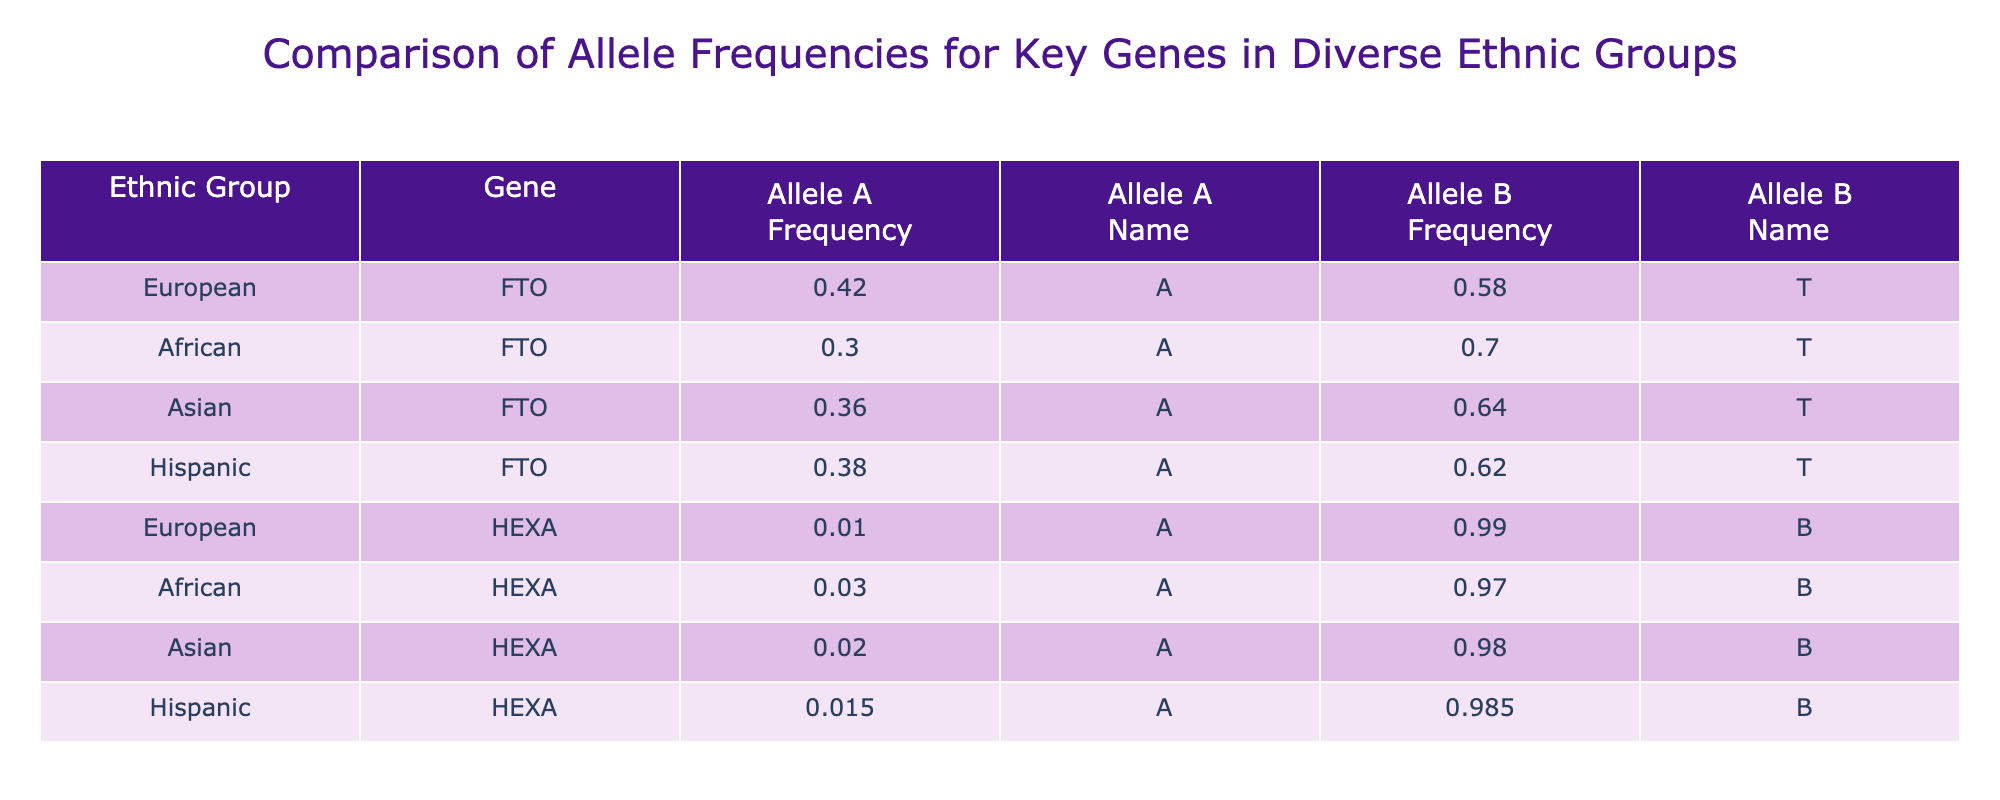What is the allele A frequency for the FTO gene in the African group? The table shows that for the FTO gene in the African group, the Allele A Frequency is 0.30.
Answer: 0.30 Which ethnic group has the highest frequency of Allele A for the HEXA gene? Looking at the HEXA gene rows, the frequencies of Allele A are 0.01 for European, 0.03 for African, 0.02 for Asian, and 0.015 for Hispanic. The European group has the highest frequency of 0.01.
Answer: European What is the total frequency of Allele B across all ethnic groups for the FTO gene? For the FTO gene, the frequencies of Allele B are 0.58 for European, 0.70 for African, 0.64 for Asian, and 0.62 for Hispanic. Adding these gives 0.58 + 0.70 + 0.64 + 0.62 = 2.54.
Answer: 2.54 Is the frequency of Allele A for the FTO gene higher in the Hispanic group than in the Asian group? The frequency of Allele A for FTO in Hispanic is 0.38, while for Asian it is 0.36. Since 0.38 is greater than 0.36, the statement is true.
Answer: Yes What is the average frequency of Allele A for the HEXA gene among the ethnic groups listed? To find the average frequency of Allele A for HEXA, we take the values: 0.01 (European), 0.03 (African), 0.02 (Asian), and 0.015 (Hispanic). Adding them gives 0.01 + 0.03 + 0.02 + 0.015 = 0.075. Dividing this by the number of groups, which is 4, we have 0.075 / 4 = 0.01875.
Answer: 0.01875 